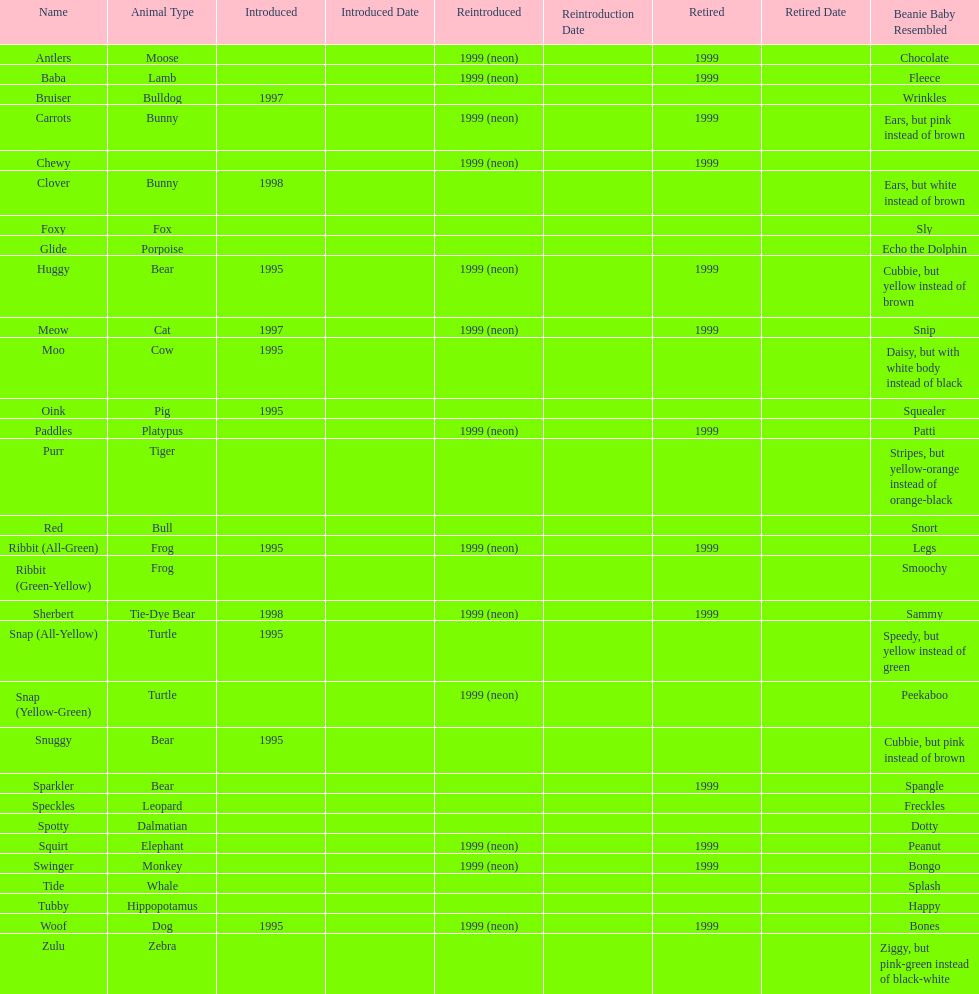What animals are pillow pals? Moose, Lamb, Bulldog, Bunny, Bunny, Fox, Porpoise, Bear, Cat, Cow, Pig, Platypus, Tiger, Bull, Frog, Frog, Tie-Dye Bear, Turtle, Turtle, Bear, Bear, Leopard, Dalmatian, Elephant, Monkey, Whale, Hippopotamus, Dog, Zebra. What is the name of the dalmatian? Spotty. 